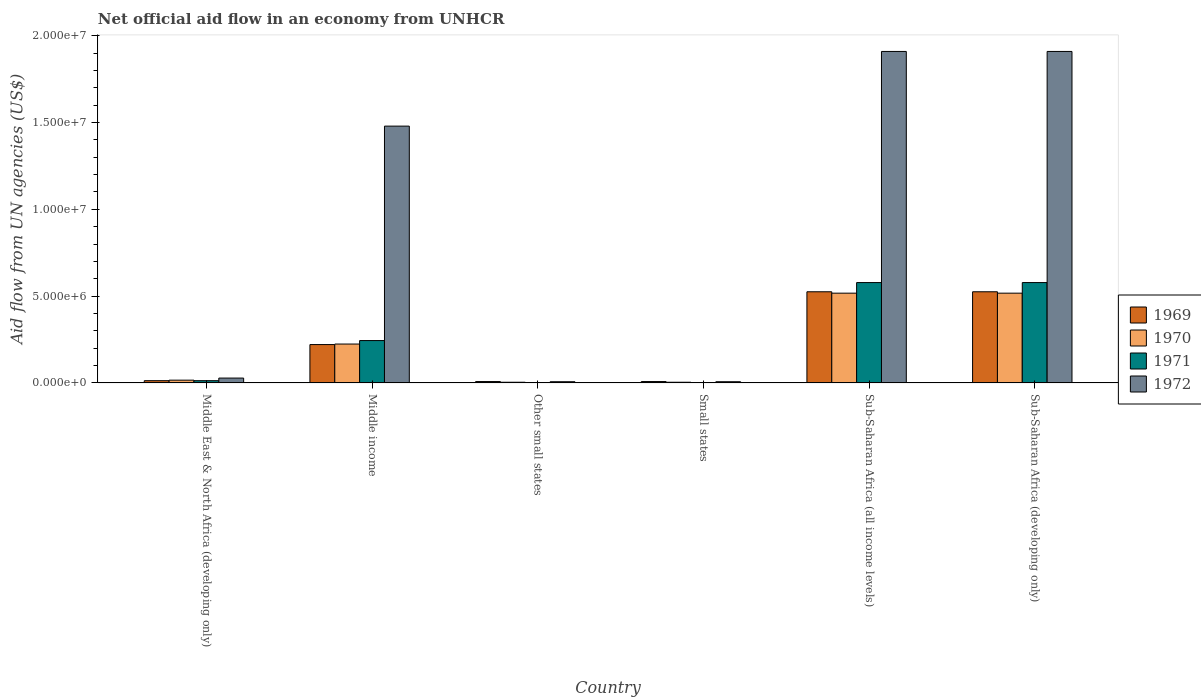How many groups of bars are there?
Make the answer very short. 6. Are the number of bars per tick equal to the number of legend labels?
Provide a succinct answer. Yes. Are the number of bars on each tick of the X-axis equal?
Offer a very short reply. Yes. How many bars are there on the 3rd tick from the left?
Provide a succinct answer. 4. How many bars are there on the 3rd tick from the right?
Offer a terse response. 4. What is the label of the 5th group of bars from the left?
Make the answer very short. Sub-Saharan Africa (all income levels). In how many cases, is the number of bars for a given country not equal to the number of legend labels?
Provide a succinct answer. 0. Across all countries, what is the maximum net official aid flow in 1969?
Give a very brief answer. 5.25e+06. Across all countries, what is the minimum net official aid flow in 1972?
Your answer should be very brief. 7.00e+04. In which country was the net official aid flow in 1971 maximum?
Provide a short and direct response. Sub-Saharan Africa (all income levels). In which country was the net official aid flow in 1971 minimum?
Your response must be concise. Other small states. What is the total net official aid flow in 1970 in the graph?
Give a very brief answer. 1.28e+07. What is the difference between the net official aid flow in 1970 in Middle income and that in Small states?
Provide a succinct answer. 2.20e+06. What is the difference between the net official aid flow in 1971 in Small states and the net official aid flow in 1969 in Other small states?
Keep it short and to the point. -6.00e+04. What is the average net official aid flow in 1969 per country?
Ensure brevity in your answer.  2.17e+06. What is the difference between the net official aid flow of/in 1972 and net official aid flow of/in 1969 in Sub-Saharan Africa (all income levels)?
Keep it short and to the point. 1.38e+07. In how many countries, is the net official aid flow in 1971 greater than 17000000 US$?
Your answer should be very brief. 0. What is the ratio of the net official aid flow in 1969 in Middle East & North Africa (developing only) to that in Sub-Saharan Africa (all income levels)?
Provide a short and direct response. 0.02. Is the net official aid flow in 1969 in Middle East & North Africa (developing only) less than that in Small states?
Keep it short and to the point. No. Is the difference between the net official aid flow in 1972 in Other small states and Sub-Saharan Africa (all income levels) greater than the difference between the net official aid flow in 1969 in Other small states and Sub-Saharan Africa (all income levels)?
Provide a succinct answer. No. What is the difference between the highest and the second highest net official aid flow in 1972?
Keep it short and to the point. 4.30e+06. What is the difference between the highest and the lowest net official aid flow in 1969?
Give a very brief answer. 5.17e+06. In how many countries, is the net official aid flow in 1971 greater than the average net official aid flow in 1971 taken over all countries?
Make the answer very short. 3. What does the 1st bar from the left in Middle East & North Africa (developing only) represents?
Offer a terse response. 1969. What does the 1st bar from the right in Sub-Saharan Africa (developing only) represents?
Ensure brevity in your answer.  1972. Is it the case that in every country, the sum of the net official aid flow in 1972 and net official aid flow in 1969 is greater than the net official aid flow in 1970?
Your response must be concise. Yes. Are all the bars in the graph horizontal?
Provide a short and direct response. No. How many countries are there in the graph?
Offer a terse response. 6. Does the graph contain grids?
Ensure brevity in your answer.  No. Where does the legend appear in the graph?
Keep it short and to the point. Center right. How many legend labels are there?
Provide a succinct answer. 4. What is the title of the graph?
Your answer should be compact. Net official aid flow in an economy from UNHCR. Does "1979" appear as one of the legend labels in the graph?
Your answer should be compact. No. What is the label or title of the X-axis?
Offer a very short reply. Country. What is the label or title of the Y-axis?
Offer a very short reply. Aid flow from UN agencies (US$). What is the Aid flow from UN agencies (US$) in 1970 in Middle East & North Africa (developing only)?
Offer a terse response. 1.60e+05. What is the Aid flow from UN agencies (US$) of 1972 in Middle East & North Africa (developing only)?
Provide a short and direct response. 2.80e+05. What is the Aid flow from UN agencies (US$) in 1969 in Middle income?
Provide a short and direct response. 2.21e+06. What is the Aid flow from UN agencies (US$) of 1970 in Middle income?
Offer a very short reply. 2.24e+06. What is the Aid flow from UN agencies (US$) of 1971 in Middle income?
Offer a very short reply. 2.44e+06. What is the Aid flow from UN agencies (US$) of 1972 in Middle income?
Provide a succinct answer. 1.48e+07. What is the Aid flow from UN agencies (US$) of 1970 in Other small states?
Your answer should be very brief. 4.00e+04. What is the Aid flow from UN agencies (US$) in 1972 in Other small states?
Make the answer very short. 7.00e+04. What is the Aid flow from UN agencies (US$) of 1969 in Small states?
Your answer should be very brief. 8.00e+04. What is the Aid flow from UN agencies (US$) in 1970 in Small states?
Your answer should be very brief. 4.00e+04. What is the Aid flow from UN agencies (US$) in 1971 in Small states?
Your response must be concise. 2.00e+04. What is the Aid flow from UN agencies (US$) of 1969 in Sub-Saharan Africa (all income levels)?
Ensure brevity in your answer.  5.25e+06. What is the Aid flow from UN agencies (US$) of 1970 in Sub-Saharan Africa (all income levels)?
Provide a succinct answer. 5.17e+06. What is the Aid flow from UN agencies (US$) of 1971 in Sub-Saharan Africa (all income levels)?
Your answer should be very brief. 5.78e+06. What is the Aid flow from UN agencies (US$) of 1972 in Sub-Saharan Africa (all income levels)?
Your response must be concise. 1.91e+07. What is the Aid flow from UN agencies (US$) of 1969 in Sub-Saharan Africa (developing only)?
Make the answer very short. 5.25e+06. What is the Aid flow from UN agencies (US$) of 1970 in Sub-Saharan Africa (developing only)?
Keep it short and to the point. 5.17e+06. What is the Aid flow from UN agencies (US$) in 1971 in Sub-Saharan Africa (developing only)?
Make the answer very short. 5.78e+06. What is the Aid flow from UN agencies (US$) in 1972 in Sub-Saharan Africa (developing only)?
Ensure brevity in your answer.  1.91e+07. Across all countries, what is the maximum Aid flow from UN agencies (US$) of 1969?
Make the answer very short. 5.25e+06. Across all countries, what is the maximum Aid flow from UN agencies (US$) of 1970?
Your answer should be very brief. 5.17e+06. Across all countries, what is the maximum Aid flow from UN agencies (US$) in 1971?
Make the answer very short. 5.78e+06. Across all countries, what is the maximum Aid flow from UN agencies (US$) of 1972?
Your answer should be compact. 1.91e+07. Across all countries, what is the minimum Aid flow from UN agencies (US$) in 1969?
Give a very brief answer. 8.00e+04. Across all countries, what is the minimum Aid flow from UN agencies (US$) in 1971?
Your answer should be very brief. 2.00e+04. What is the total Aid flow from UN agencies (US$) of 1969 in the graph?
Your answer should be compact. 1.30e+07. What is the total Aid flow from UN agencies (US$) of 1970 in the graph?
Ensure brevity in your answer.  1.28e+07. What is the total Aid flow from UN agencies (US$) of 1971 in the graph?
Give a very brief answer. 1.42e+07. What is the total Aid flow from UN agencies (US$) in 1972 in the graph?
Give a very brief answer. 5.34e+07. What is the difference between the Aid flow from UN agencies (US$) of 1969 in Middle East & North Africa (developing only) and that in Middle income?
Keep it short and to the point. -2.08e+06. What is the difference between the Aid flow from UN agencies (US$) in 1970 in Middle East & North Africa (developing only) and that in Middle income?
Your answer should be very brief. -2.08e+06. What is the difference between the Aid flow from UN agencies (US$) in 1971 in Middle East & North Africa (developing only) and that in Middle income?
Your response must be concise. -2.31e+06. What is the difference between the Aid flow from UN agencies (US$) in 1972 in Middle East & North Africa (developing only) and that in Middle income?
Make the answer very short. -1.45e+07. What is the difference between the Aid flow from UN agencies (US$) of 1969 in Middle East & North Africa (developing only) and that in Other small states?
Make the answer very short. 5.00e+04. What is the difference between the Aid flow from UN agencies (US$) of 1970 in Middle East & North Africa (developing only) and that in Other small states?
Make the answer very short. 1.20e+05. What is the difference between the Aid flow from UN agencies (US$) of 1971 in Middle East & North Africa (developing only) and that in Other small states?
Ensure brevity in your answer.  1.10e+05. What is the difference between the Aid flow from UN agencies (US$) of 1972 in Middle East & North Africa (developing only) and that in Small states?
Your answer should be compact. 2.10e+05. What is the difference between the Aid flow from UN agencies (US$) of 1969 in Middle East & North Africa (developing only) and that in Sub-Saharan Africa (all income levels)?
Make the answer very short. -5.12e+06. What is the difference between the Aid flow from UN agencies (US$) of 1970 in Middle East & North Africa (developing only) and that in Sub-Saharan Africa (all income levels)?
Offer a terse response. -5.01e+06. What is the difference between the Aid flow from UN agencies (US$) in 1971 in Middle East & North Africa (developing only) and that in Sub-Saharan Africa (all income levels)?
Keep it short and to the point. -5.65e+06. What is the difference between the Aid flow from UN agencies (US$) of 1972 in Middle East & North Africa (developing only) and that in Sub-Saharan Africa (all income levels)?
Provide a succinct answer. -1.88e+07. What is the difference between the Aid flow from UN agencies (US$) in 1969 in Middle East & North Africa (developing only) and that in Sub-Saharan Africa (developing only)?
Keep it short and to the point. -5.12e+06. What is the difference between the Aid flow from UN agencies (US$) in 1970 in Middle East & North Africa (developing only) and that in Sub-Saharan Africa (developing only)?
Make the answer very short. -5.01e+06. What is the difference between the Aid flow from UN agencies (US$) in 1971 in Middle East & North Africa (developing only) and that in Sub-Saharan Africa (developing only)?
Your answer should be compact. -5.65e+06. What is the difference between the Aid flow from UN agencies (US$) of 1972 in Middle East & North Africa (developing only) and that in Sub-Saharan Africa (developing only)?
Keep it short and to the point. -1.88e+07. What is the difference between the Aid flow from UN agencies (US$) in 1969 in Middle income and that in Other small states?
Make the answer very short. 2.13e+06. What is the difference between the Aid flow from UN agencies (US$) in 1970 in Middle income and that in Other small states?
Offer a very short reply. 2.20e+06. What is the difference between the Aid flow from UN agencies (US$) of 1971 in Middle income and that in Other small states?
Provide a short and direct response. 2.42e+06. What is the difference between the Aid flow from UN agencies (US$) in 1972 in Middle income and that in Other small states?
Your answer should be very brief. 1.47e+07. What is the difference between the Aid flow from UN agencies (US$) of 1969 in Middle income and that in Small states?
Give a very brief answer. 2.13e+06. What is the difference between the Aid flow from UN agencies (US$) of 1970 in Middle income and that in Small states?
Ensure brevity in your answer.  2.20e+06. What is the difference between the Aid flow from UN agencies (US$) in 1971 in Middle income and that in Small states?
Your response must be concise. 2.42e+06. What is the difference between the Aid flow from UN agencies (US$) in 1972 in Middle income and that in Small states?
Your answer should be compact. 1.47e+07. What is the difference between the Aid flow from UN agencies (US$) of 1969 in Middle income and that in Sub-Saharan Africa (all income levels)?
Offer a terse response. -3.04e+06. What is the difference between the Aid flow from UN agencies (US$) in 1970 in Middle income and that in Sub-Saharan Africa (all income levels)?
Offer a very short reply. -2.93e+06. What is the difference between the Aid flow from UN agencies (US$) in 1971 in Middle income and that in Sub-Saharan Africa (all income levels)?
Your answer should be compact. -3.34e+06. What is the difference between the Aid flow from UN agencies (US$) in 1972 in Middle income and that in Sub-Saharan Africa (all income levels)?
Keep it short and to the point. -4.30e+06. What is the difference between the Aid flow from UN agencies (US$) in 1969 in Middle income and that in Sub-Saharan Africa (developing only)?
Your answer should be very brief. -3.04e+06. What is the difference between the Aid flow from UN agencies (US$) in 1970 in Middle income and that in Sub-Saharan Africa (developing only)?
Provide a short and direct response. -2.93e+06. What is the difference between the Aid flow from UN agencies (US$) in 1971 in Middle income and that in Sub-Saharan Africa (developing only)?
Provide a short and direct response. -3.34e+06. What is the difference between the Aid flow from UN agencies (US$) of 1972 in Middle income and that in Sub-Saharan Africa (developing only)?
Make the answer very short. -4.30e+06. What is the difference between the Aid flow from UN agencies (US$) in 1969 in Other small states and that in Small states?
Ensure brevity in your answer.  0. What is the difference between the Aid flow from UN agencies (US$) of 1970 in Other small states and that in Small states?
Offer a terse response. 0. What is the difference between the Aid flow from UN agencies (US$) in 1971 in Other small states and that in Small states?
Your answer should be very brief. 0. What is the difference between the Aid flow from UN agencies (US$) of 1969 in Other small states and that in Sub-Saharan Africa (all income levels)?
Offer a very short reply. -5.17e+06. What is the difference between the Aid flow from UN agencies (US$) in 1970 in Other small states and that in Sub-Saharan Africa (all income levels)?
Provide a succinct answer. -5.13e+06. What is the difference between the Aid flow from UN agencies (US$) in 1971 in Other small states and that in Sub-Saharan Africa (all income levels)?
Keep it short and to the point. -5.76e+06. What is the difference between the Aid flow from UN agencies (US$) in 1972 in Other small states and that in Sub-Saharan Africa (all income levels)?
Offer a terse response. -1.90e+07. What is the difference between the Aid flow from UN agencies (US$) in 1969 in Other small states and that in Sub-Saharan Africa (developing only)?
Make the answer very short. -5.17e+06. What is the difference between the Aid flow from UN agencies (US$) of 1970 in Other small states and that in Sub-Saharan Africa (developing only)?
Your response must be concise. -5.13e+06. What is the difference between the Aid flow from UN agencies (US$) in 1971 in Other small states and that in Sub-Saharan Africa (developing only)?
Your answer should be very brief. -5.76e+06. What is the difference between the Aid flow from UN agencies (US$) in 1972 in Other small states and that in Sub-Saharan Africa (developing only)?
Provide a short and direct response. -1.90e+07. What is the difference between the Aid flow from UN agencies (US$) of 1969 in Small states and that in Sub-Saharan Africa (all income levels)?
Offer a very short reply. -5.17e+06. What is the difference between the Aid flow from UN agencies (US$) of 1970 in Small states and that in Sub-Saharan Africa (all income levels)?
Provide a succinct answer. -5.13e+06. What is the difference between the Aid flow from UN agencies (US$) of 1971 in Small states and that in Sub-Saharan Africa (all income levels)?
Make the answer very short. -5.76e+06. What is the difference between the Aid flow from UN agencies (US$) of 1972 in Small states and that in Sub-Saharan Africa (all income levels)?
Offer a terse response. -1.90e+07. What is the difference between the Aid flow from UN agencies (US$) in 1969 in Small states and that in Sub-Saharan Africa (developing only)?
Your response must be concise. -5.17e+06. What is the difference between the Aid flow from UN agencies (US$) in 1970 in Small states and that in Sub-Saharan Africa (developing only)?
Ensure brevity in your answer.  -5.13e+06. What is the difference between the Aid flow from UN agencies (US$) in 1971 in Small states and that in Sub-Saharan Africa (developing only)?
Ensure brevity in your answer.  -5.76e+06. What is the difference between the Aid flow from UN agencies (US$) of 1972 in Small states and that in Sub-Saharan Africa (developing only)?
Your answer should be very brief. -1.90e+07. What is the difference between the Aid flow from UN agencies (US$) of 1969 in Sub-Saharan Africa (all income levels) and that in Sub-Saharan Africa (developing only)?
Your response must be concise. 0. What is the difference between the Aid flow from UN agencies (US$) in 1972 in Sub-Saharan Africa (all income levels) and that in Sub-Saharan Africa (developing only)?
Give a very brief answer. 0. What is the difference between the Aid flow from UN agencies (US$) of 1969 in Middle East & North Africa (developing only) and the Aid flow from UN agencies (US$) of 1970 in Middle income?
Your answer should be compact. -2.11e+06. What is the difference between the Aid flow from UN agencies (US$) of 1969 in Middle East & North Africa (developing only) and the Aid flow from UN agencies (US$) of 1971 in Middle income?
Your answer should be very brief. -2.31e+06. What is the difference between the Aid flow from UN agencies (US$) of 1969 in Middle East & North Africa (developing only) and the Aid flow from UN agencies (US$) of 1972 in Middle income?
Make the answer very short. -1.47e+07. What is the difference between the Aid flow from UN agencies (US$) of 1970 in Middle East & North Africa (developing only) and the Aid flow from UN agencies (US$) of 1971 in Middle income?
Keep it short and to the point. -2.28e+06. What is the difference between the Aid flow from UN agencies (US$) in 1970 in Middle East & North Africa (developing only) and the Aid flow from UN agencies (US$) in 1972 in Middle income?
Ensure brevity in your answer.  -1.46e+07. What is the difference between the Aid flow from UN agencies (US$) of 1971 in Middle East & North Africa (developing only) and the Aid flow from UN agencies (US$) of 1972 in Middle income?
Your response must be concise. -1.47e+07. What is the difference between the Aid flow from UN agencies (US$) in 1969 in Middle East & North Africa (developing only) and the Aid flow from UN agencies (US$) in 1970 in Other small states?
Your response must be concise. 9.00e+04. What is the difference between the Aid flow from UN agencies (US$) in 1969 in Middle East & North Africa (developing only) and the Aid flow from UN agencies (US$) in 1972 in Other small states?
Offer a very short reply. 6.00e+04. What is the difference between the Aid flow from UN agencies (US$) of 1970 in Middle East & North Africa (developing only) and the Aid flow from UN agencies (US$) of 1971 in Other small states?
Offer a terse response. 1.40e+05. What is the difference between the Aid flow from UN agencies (US$) of 1971 in Middle East & North Africa (developing only) and the Aid flow from UN agencies (US$) of 1972 in Other small states?
Ensure brevity in your answer.  6.00e+04. What is the difference between the Aid flow from UN agencies (US$) in 1970 in Middle East & North Africa (developing only) and the Aid flow from UN agencies (US$) in 1971 in Small states?
Your answer should be very brief. 1.40e+05. What is the difference between the Aid flow from UN agencies (US$) in 1969 in Middle East & North Africa (developing only) and the Aid flow from UN agencies (US$) in 1970 in Sub-Saharan Africa (all income levels)?
Offer a very short reply. -5.04e+06. What is the difference between the Aid flow from UN agencies (US$) in 1969 in Middle East & North Africa (developing only) and the Aid flow from UN agencies (US$) in 1971 in Sub-Saharan Africa (all income levels)?
Ensure brevity in your answer.  -5.65e+06. What is the difference between the Aid flow from UN agencies (US$) of 1969 in Middle East & North Africa (developing only) and the Aid flow from UN agencies (US$) of 1972 in Sub-Saharan Africa (all income levels)?
Your answer should be compact. -1.90e+07. What is the difference between the Aid flow from UN agencies (US$) of 1970 in Middle East & North Africa (developing only) and the Aid flow from UN agencies (US$) of 1971 in Sub-Saharan Africa (all income levels)?
Offer a very short reply. -5.62e+06. What is the difference between the Aid flow from UN agencies (US$) in 1970 in Middle East & North Africa (developing only) and the Aid flow from UN agencies (US$) in 1972 in Sub-Saharan Africa (all income levels)?
Offer a very short reply. -1.89e+07. What is the difference between the Aid flow from UN agencies (US$) in 1971 in Middle East & North Africa (developing only) and the Aid flow from UN agencies (US$) in 1972 in Sub-Saharan Africa (all income levels)?
Provide a short and direct response. -1.90e+07. What is the difference between the Aid flow from UN agencies (US$) of 1969 in Middle East & North Africa (developing only) and the Aid flow from UN agencies (US$) of 1970 in Sub-Saharan Africa (developing only)?
Provide a short and direct response. -5.04e+06. What is the difference between the Aid flow from UN agencies (US$) of 1969 in Middle East & North Africa (developing only) and the Aid flow from UN agencies (US$) of 1971 in Sub-Saharan Africa (developing only)?
Provide a succinct answer. -5.65e+06. What is the difference between the Aid flow from UN agencies (US$) in 1969 in Middle East & North Africa (developing only) and the Aid flow from UN agencies (US$) in 1972 in Sub-Saharan Africa (developing only)?
Your answer should be compact. -1.90e+07. What is the difference between the Aid flow from UN agencies (US$) in 1970 in Middle East & North Africa (developing only) and the Aid flow from UN agencies (US$) in 1971 in Sub-Saharan Africa (developing only)?
Offer a very short reply. -5.62e+06. What is the difference between the Aid flow from UN agencies (US$) in 1970 in Middle East & North Africa (developing only) and the Aid flow from UN agencies (US$) in 1972 in Sub-Saharan Africa (developing only)?
Keep it short and to the point. -1.89e+07. What is the difference between the Aid flow from UN agencies (US$) of 1971 in Middle East & North Africa (developing only) and the Aid flow from UN agencies (US$) of 1972 in Sub-Saharan Africa (developing only)?
Provide a succinct answer. -1.90e+07. What is the difference between the Aid flow from UN agencies (US$) in 1969 in Middle income and the Aid flow from UN agencies (US$) in 1970 in Other small states?
Provide a short and direct response. 2.17e+06. What is the difference between the Aid flow from UN agencies (US$) of 1969 in Middle income and the Aid flow from UN agencies (US$) of 1971 in Other small states?
Keep it short and to the point. 2.19e+06. What is the difference between the Aid flow from UN agencies (US$) in 1969 in Middle income and the Aid flow from UN agencies (US$) in 1972 in Other small states?
Give a very brief answer. 2.14e+06. What is the difference between the Aid flow from UN agencies (US$) of 1970 in Middle income and the Aid flow from UN agencies (US$) of 1971 in Other small states?
Offer a very short reply. 2.22e+06. What is the difference between the Aid flow from UN agencies (US$) in 1970 in Middle income and the Aid flow from UN agencies (US$) in 1972 in Other small states?
Provide a short and direct response. 2.17e+06. What is the difference between the Aid flow from UN agencies (US$) in 1971 in Middle income and the Aid flow from UN agencies (US$) in 1972 in Other small states?
Offer a very short reply. 2.37e+06. What is the difference between the Aid flow from UN agencies (US$) in 1969 in Middle income and the Aid flow from UN agencies (US$) in 1970 in Small states?
Make the answer very short. 2.17e+06. What is the difference between the Aid flow from UN agencies (US$) in 1969 in Middle income and the Aid flow from UN agencies (US$) in 1971 in Small states?
Offer a very short reply. 2.19e+06. What is the difference between the Aid flow from UN agencies (US$) in 1969 in Middle income and the Aid flow from UN agencies (US$) in 1972 in Small states?
Provide a short and direct response. 2.14e+06. What is the difference between the Aid flow from UN agencies (US$) of 1970 in Middle income and the Aid flow from UN agencies (US$) of 1971 in Small states?
Keep it short and to the point. 2.22e+06. What is the difference between the Aid flow from UN agencies (US$) in 1970 in Middle income and the Aid flow from UN agencies (US$) in 1972 in Small states?
Offer a very short reply. 2.17e+06. What is the difference between the Aid flow from UN agencies (US$) in 1971 in Middle income and the Aid flow from UN agencies (US$) in 1972 in Small states?
Keep it short and to the point. 2.37e+06. What is the difference between the Aid flow from UN agencies (US$) of 1969 in Middle income and the Aid flow from UN agencies (US$) of 1970 in Sub-Saharan Africa (all income levels)?
Offer a terse response. -2.96e+06. What is the difference between the Aid flow from UN agencies (US$) of 1969 in Middle income and the Aid flow from UN agencies (US$) of 1971 in Sub-Saharan Africa (all income levels)?
Provide a succinct answer. -3.57e+06. What is the difference between the Aid flow from UN agencies (US$) in 1969 in Middle income and the Aid flow from UN agencies (US$) in 1972 in Sub-Saharan Africa (all income levels)?
Keep it short and to the point. -1.69e+07. What is the difference between the Aid flow from UN agencies (US$) in 1970 in Middle income and the Aid flow from UN agencies (US$) in 1971 in Sub-Saharan Africa (all income levels)?
Ensure brevity in your answer.  -3.54e+06. What is the difference between the Aid flow from UN agencies (US$) of 1970 in Middle income and the Aid flow from UN agencies (US$) of 1972 in Sub-Saharan Africa (all income levels)?
Provide a short and direct response. -1.68e+07. What is the difference between the Aid flow from UN agencies (US$) of 1971 in Middle income and the Aid flow from UN agencies (US$) of 1972 in Sub-Saharan Africa (all income levels)?
Give a very brief answer. -1.66e+07. What is the difference between the Aid flow from UN agencies (US$) of 1969 in Middle income and the Aid flow from UN agencies (US$) of 1970 in Sub-Saharan Africa (developing only)?
Make the answer very short. -2.96e+06. What is the difference between the Aid flow from UN agencies (US$) in 1969 in Middle income and the Aid flow from UN agencies (US$) in 1971 in Sub-Saharan Africa (developing only)?
Give a very brief answer. -3.57e+06. What is the difference between the Aid flow from UN agencies (US$) of 1969 in Middle income and the Aid flow from UN agencies (US$) of 1972 in Sub-Saharan Africa (developing only)?
Make the answer very short. -1.69e+07. What is the difference between the Aid flow from UN agencies (US$) of 1970 in Middle income and the Aid flow from UN agencies (US$) of 1971 in Sub-Saharan Africa (developing only)?
Provide a short and direct response. -3.54e+06. What is the difference between the Aid flow from UN agencies (US$) in 1970 in Middle income and the Aid flow from UN agencies (US$) in 1972 in Sub-Saharan Africa (developing only)?
Provide a short and direct response. -1.68e+07. What is the difference between the Aid flow from UN agencies (US$) in 1971 in Middle income and the Aid flow from UN agencies (US$) in 1972 in Sub-Saharan Africa (developing only)?
Your answer should be compact. -1.66e+07. What is the difference between the Aid flow from UN agencies (US$) in 1969 in Other small states and the Aid flow from UN agencies (US$) in 1971 in Small states?
Your response must be concise. 6.00e+04. What is the difference between the Aid flow from UN agencies (US$) of 1969 in Other small states and the Aid flow from UN agencies (US$) of 1970 in Sub-Saharan Africa (all income levels)?
Provide a succinct answer. -5.09e+06. What is the difference between the Aid flow from UN agencies (US$) of 1969 in Other small states and the Aid flow from UN agencies (US$) of 1971 in Sub-Saharan Africa (all income levels)?
Your answer should be very brief. -5.70e+06. What is the difference between the Aid flow from UN agencies (US$) in 1969 in Other small states and the Aid flow from UN agencies (US$) in 1972 in Sub-Saharan Africa (all income levels)?
Your answer should be very brief. -1.90e+07. What is the difference between the Aid flow from UN agencies (US$) of 1970 in Other small states and the Aid flow from UN agencies (US$) of 1971 in Sub-Saharan Africa (all income levels)?
Your answer should be compact. -5.74e+06. What is the difference between the Aid flow from UN agencies (US$) in 1970 in Other small states and the Aid flow from UN agencies (US$) in 1972 in Sub-Saharan Africa (all income levels)?
Offer a terse response. -1.90e+07. What is the difference between the Aid flow from UN agencies (US$) in 1971 in Other small states and the Aid flow from UN agencies (US$) in 1972 in Sub-Saharan Africa (all income levels)?
Give a very brief answer. -1.91e+07. What is the difference between the Aid flow from UN agencies (US$) of 1969 in Other small states and the Aid flow from UN agencies (US$) of 1970 in Sub-Saharan Africa (developing only)?
Your answer should be very brief. -5.09e+06. What is the difference between the Aid flow from UN agencies (US$) in 1969 in Other small states and the Aid flow from UN agencies (US$) in 1971 in Sub-Saharan Africa (developing only)?
Ensure brevity in your answer.  -5.70e+06. What is the difference between the Aid flow from UN agencies (US$) of 1969 in Other small states and the Aid flow from UN agencies (US$) of 1972 in Sub-Saharan Africa (developing only)?
Keep it short and to the point. -1.90e+07. What is the difference between the Aid flow from UN agencies (US$) of 1970 in Other small states and the Aid flow from UN agencies (US$) of 1971 in Sub-Saharan Africa (developing only)?
Make the answer very short. -5.74e+06. What is the difference between the Aid flow from UN agencies (US$) in 1970 in Other small states and the Aid flow from UN agencies (US$) in 1972 in Sub-Saharan Africa (developing only)?
Give a very brief answer. -1.90e+07. What is the difference between the Aid flow from UN agencies (US$) in 1971 in Other small states and the Aid flow from UN agencies (US$) in 1972 in Sub-Saharan Africa (developing only)?
Keep it short and to the point. -1.91e+07. What is the difference between the Aid flow from UN agencies (US$) of 1969 in Small states and the Aid flow from UN agencies (US$) of 1970 in Sub-Saharan Africa (all income levels)?
Provide a short and direct response. -5.09e+06. What is the difference between the Aid flow from UN agencies (US$) of 1969 in Small states and the Aid flow from UN agencies (US$) of 1971 in Sub-Saharan Africa (all income levels)?
Offer a very short reply. -5.70e+06. What is the difference between the Aid flow from UN agencies (US$) in 1969 in Small states and the Aid flow from UN agencies (US$) in 1972 in Sub-Saharan Africa (all income levels)?
Provide a succinct answer. -1.90e+07. What is the difference between the Aid flow from UN agencies (US$) of 1970 in Small states and the Aid flow from UN agencies (US$) of 1971 in Sub-Saharan Africa (all income levels)?
Keep it short and to the point. -5.74e+06. What is the difference between the Aid flow from UN agencies (US$) in 1970 in Small states and the Aid flow from UN agencies (US$) in 1972 in Sub-Saharan Africa (all income levels)?
Give a very brief answer. -1.90e+07. What is the difference between the Aid flow from UN agencies (US$) in 1971 in Small states and the Aid flow from UN agencies (US$) in 1972 in Sub-Saharan Africa (all income levels)?
Provide a short and direct response. -1.91e+07. What is the difference between the Aid flow from UN agencies (US$) in 1969 in Small states and the Aid flow from UN agencies (US$) in 1970 in Sub-Saharan Africa (developing only)?
Provide a succinct answer. -5.09e+06. What is the difference between the Aid flow from UN agencies (US$) in 1969 in Small states and the Aid flow from UN agencies (US$) in 1971 in Sub-Saharan Africa (developing only)?
Provide a succinct answer. -5.70e+06. What is the difference between the Aid flow from UN agencies (US$) in 1969 in Small states and the Aid flow from UN agencies (US$) in 1972 in Sub-Saharan Africa (developing only)?
Offer a terse response. -1.90e+07. What is the difference between the Aid flow from UN agencies (US$) of 1970 in Small states and the Aid flow from UN agencies (US$) of 1971 in Sub-Saharan Africa (developing only)?
Your answer should be compact. -5.74e+06. What is the difference between the Aid flow from UN agencies (US$) in 1970 in Small states and the Aid flow from UN agencies (US$) in 1972 in Sub-Saharan Africa (developing only)?
Keep it short and to the point. -1.90e+07. What is the difference between the Aid flow from UN agencies (US$) in 1971 in Small states and the Aid flow from UN agencies (US$) in 1972 in Sub-Saharan Africa (developing only)?
Offer a terse response. -1.91e+07. What is the difference between the Aid flow from UN agencies (US$) in 1969 in Sub-Saharan Africa (all income levels) and the Aid flow from UN agencies (US$) in 1970 in Sub-Saharan Africa (developing only)?
Provide a short and direct response. 8.00e+04. What is the difference between the Aid flow from UN agencies (US$) of 1969 in Sub-Saharan Africa (all income levels) and the Aid flow from UN agencies (US$) of 1971 in Sub-Saharan Africa (developing only)?
Offer a terse response. -5.30e+05. What is the difference between the Aid flow from UN agencies (US$) of 1969 in Sub-Saharan Africa (all income levels) and the Aid flow from UN agencies (US$) of 1972 in Sub-Saharan Africa (developing only)?
Provide a short and direct response. -1.38e+07. What is the difference between the Aid flow from UN agencies (US$) in 1970 in Sub-Saharan Africa (all income levels) and the Aid flow from UN agencies (US$) in 1971 in Sub-Saharan Africa (developing only)?
Offer a terse response. -6.10e+05. What is the difference between the Aid flow from UN agencies (US$) in 1970 in Sub-Saharan Africa (all income levels) and the Aid flow from UN agencies (US$) in 1972 in Sub-Saharan Africa (developing only)?
Your answer should be very brief. -1.39e+07. What is the difference between the Aid flow from UN agencies (US$) in 1971 in Sub-Saharan Africa (all income levels) and the Aid flow from UN agencies (US$) in 1972 in Sub-Saharan Africa (developing only)?
Make the answer very short. -1.33e+07. What is the average Aid flow from UN agencies (US$) in 1969 per country?
Offer a very short reply. 2.17e+06. What is the average Aid flow from UN agencies (US$) of 1970 per country?
Give a very brief answer. 2.14e+06. What is the average Aid flow from UN agencies (US$) of 1971 per country?
Ensure brevity in your answer.  2.36e+06. What is the average Aid flow from UN agencies (US$) of 1972 per country?
Offer a terse response. 8.90e+06. What is the difference between the Aid flow from UN agencies (US$) of 1969 and Aid flow from UN agencies (US$) of 1970 in Middle East & North Africa (developing only)?
Provide a succinct answer. -3.00e+04. What is the difference between the Aid flow from UN agencies (US$) in 1969 and Aid flow from UN agencies (US$) in 1971 in Middle East & North Africa (developing only)?
Make the answer very short. 0. What is the difference between the Aid flow from UN agencies (US$) of 1969 and Aid flow from UN agencies (US$) of 1972 in Middle East & North Africa (developing only)?
Provide a succinct answer. -1.50e+05. What is the difference between the Aid flow from UN agencies (US$) in 1970 and Aid flow from UN agencies (US$) in 1972 in Middle East & North Africa (developing only)?
Your response must be concise. -1.20e+05. What is the difference between the Aid flow from UN agencies (US$) of 1971 and Aid flow from UN agencies (US$) of 1972 in Middle East & North Africa (developing only)?
Offer a very short reply. -1.50e+05. What is the difference between the Aid flow from UN agencies (US$) of 1969 and Aid flow from UN agencies (US$) of 1970 in Middle income?
Provide a succinct answer. -3.00e+04. What is the difference between the Aid flow from UN agencies (US$) in 1969 and Aid flow from UN agencies (US$) in 1972 in Middle income?
Your answer should be very brief. -1.26e+07. What is the difference between the Aid flow from UN agencies (US$) in 1970 and Aid flow from UN agencies (US$) in 1971 in Middle income?
Keep it short and to the point. -2.00e+05. What is the difference between the Aid flow from UN agencies (US$) in 1970 and Aid flow from UN agencies (US$) in 1972 in Middle income?
Give a very brief answer. -1.26e+07. What is the difference between the Aid flow from UN agencies (US$) of 1971 and Aid flow from UN agencies (US$) of 1972 in Middle income?
Offer a terse response. -1.24e+07. What is the difference between the Aid flow from UN agencies (US$) in 1970 and Aid flow from UN agencies (US$) in 1972 in Other small states?
Keep it short and to the point. -3.00e+04. What is the difference between the Aid flow from UN agencies (US$) of 1969 and Aid flow from UN agencies (US$) of 1970 in Small states?
Keep it short and to the point. 4.00e+04. What is the difference between the Aid flow from UN agencies (US$) in 1970 and Aid flow from UN agencies (US$) in 1971 in Small states?
Your answer should be compact. 2.00e+04. What is the difference between the Aid flow from UN agencies (US$) of 1971 and Aid flow from UN agencies (US$) of 1972 in Small states?
Offer a terse response. -5.00e+04. What is the difference between the Aid flow from UN agencies (US$) of 1969 and Aid flow from UN agencies (US$) of 1971 in Sub-Saharan Africa (all income levels)?
Make the answer very short. -5.30e+05. What is the difference between the Aid flow from UN agencies (US$) of 1969 and Aid flow from UN agencies (US$) of 1972 in Sub-Saharan Africa (all income levels)?
Offer a terse response. -1.38e+07. What is the difference between the Aid flow from UN agencies (US$) of 1970 and Aid flow from UN agencies (US$) of 1971 in Sub-Saharan Africa (all income levels)?
Offer a very short reply. -6.10e+05. What is the difference between the Aid flow from UN agencies (US$) of 1970 and Aid flow from UN agencies (US$) of 1972 in Sub-Saharan Africa (all income levels)?
Keep it short and to the point. -1.39e+07. What is the difference between the Aid flow from UN agencies (US$) of 1971 and Aid flow from UN agencies (US$) of 1972 in Sub-Saharan Africa (all income levels)?
Provide a short and direct response. -1.33e+07. What is the difference between the Aid flow from UN agencies (US$) of 1969 and Aid flow from UN agencies (US$) of 1970 in Sub-Saharan Africa (developing only)?
Offer a very short reply. 8.00e+04. What is the difference between the Aid flow from UN agencies (US$) in 1969 and Aid flow from UN agencies (US$) in 1971 in Sub-Saharan Africa (developing only)?
Give a very brief answer. -5.30e+05. What is the difference between the Aid flow from UN agencies (US$) in 1969 and Aid flow from UN agencies (US$) in 1972 in Sub-Saharan Africa (developing only)?
Offer a terse response. -1.38e+07. What is the difference between the Aid flow from UN agencies (US$) of 1970 and Aid flow from UN agencies (US$) of 1971 in Sub-Saharan Africa (developing only)?
Provide a short and direct response. -6.10e+05. What is the difference between the Aid flow from UN agencies (US$) in 1970 and Aid flow from UN agencies (US$) in 1972 in Sub-Saharan Africa (developing only)?
Your answer should be compact. -1.39e+07. What is the difference between the Aid flow from UN agencies (US$) in 1971 and Aid flow from UN agencies (US$) in 1972 in Sub-Saharan Africa (developing only)?
Your answer should be very brief. -1.33e+07. What is the ratio of the Aid flow from UN agencies (US$) of 1969 in Middle East & North Africa (developing only) to that in Middle income?
Make the answer very short. 0.06. What is the ratio of the Aid flow from UN agencies (US$) in 1970 in Middle East & North Africa (developing only) to that in Middle income?
Provide a succinct answer. 0.07. What is the ratio of the Aid flow from UN agencies (US$) in 1971 in Middle East & North Africa (developing only) to that in Middle income?
Give a very brief answer. 0.05. What is the ratio of the Aid flow from UN agencies (US$) of 1972 in Middle East & North Africa (developing only) to that in Middle income?
Provide a succinct answer. 0.02. What is the ratio of the Aid flow from UN agencies (US$) of 1969 in Middle East & North Africa (developing only) to that in Other small states?
Offer a terse response. 1.62. What is the ratio of the Aid flow from UN agencies (US$) of 1971 in Middle East & North Africa (developing only) to that in Other small states?
Your response must be concise. 6.5. What is the ratio of the Aid flow from UN agencies (US$) of 1972 in Middle East & North Africa (developing only) to that in Other small states?
Provide a succinct answer. 4. What is the ratio of the Aid flow from UN agencies (US$) in 1969 in Middle East & North Africa (developing only) to that in Small states?
Your answer should be very brief. 1.62. What is the ratio of the Aid flow from UN agencies (US$) of 1971 in Middle East & North Africa (developing only) to that in Small states?
Provide a succinct answer. 6.5. What is the ratio of the Aid flow from UN agencies (US$) of 1969 in Middle East & North Africa (developing only) to that in Sub-Saharan Africa (all income levels)?
Offer a very short reply. 0.02. What is the ratio of the Aid flow from UN agencies (US$) of 1970 in Middle East & North Africa (developing only) to that in Sub-Saharan Africa (all income levels)?
Give a very brief answer. 0.03. What is the ratio of the Aid flow from UN agencies (US$) in 1971 in Middle East & North Africa (developing only) to that in Sub-Saharan Africa (all income levels)?
Offer a very short reply. 0.02. What is the ratio of the Aid flow from UN agencies (US$) of 1972 in Middle East & North Africa (developing only) to that in Sub-Saharan Africa (all income levels)?
Keep it short and to the point. 0.01. What is the ratio of the Aid flow from UN agencies (US$) of 1969 in Middle East & North Africa (developing only) to that in Sub-Saharan Africa (developing only)?
Your answer should be compact. 0.02. What is the ratio of the Aid flow from UN agencies (US$) in 1970 in Middle East & North Africa (developing only) to that in Sub-Saharan Africa (developing only)?
Make the answer very short. 0.03. What is the ratio of the Aid flow from UN agencies (US$) of 1971 in Middle East & North Africa (developing only) to that in Sub-Saharan Africa (developing only)?
Your answer should be very brief. 0.02. What is the ratio of the Aid flow from UN agencies (US$) in 1972 in Middle East & North Africa (developing only) to that in Sub-Saharan Africa (developing only)?
Keep it short and to the point. 0.01. What is the ratio of the Aid flow from UN agencies (US$) of 1969 in Middle income to that in Other small states?
Make the answer very short. 27.62. What is the ratio of the Aid flow from UN agencies (US$) in 1971 in Middle income to that in Other small states?
Ensure brevity in your answer.  122. What is the ratio of the Aid flow from UN agencies (US$) of 1972 in Middle income to that in Other small states?
Keep it short and to the point. 211.29. What is the ratio of the Aid flow from UN agencies (US$) in 1969 in Middle income to that in Small states?
Provide a short and direct response. 27.62. What is the ratio of the Aid flow from UN agencies (US$) of 1970 in Middle income to that in Small states?
Offer a terse response. 56. What is the ratio of the Aid flow from UN agencies (US$) in 1971 in Middle income to that in Small states?
Offer a very short reply. 122. What is the ratio of the Aid flow from UN agencies (US$) of 1972 in Middle income to that in Small states?
Offer a very short reply. 211.29. What is the ratio of the Aid flow from UN agencies (US$) in 1969 in Middle income to that in Sub-Saharan Africa (all income levels)?
Your response must be concise. 0.42. What is the ratio of the Aid flow from UN agencies (US$) of 1970 in Middle income to that in Sub-Saharan Africa (all income levels)?
Provide a short and direct response. 0.43. What is the ratio of the Aid flow from UN agencies (US$) of 1971 in Middle income to that in Sub-Saharan Africa (all income levels)?
Keep it short and to the point. 0.42. What is the ratio of the Aid flow from UN agencies (US$) of 1972 in Middle income to that in Sub-Saharan Africa (all income levels)?
Your answer should be very brief. 0.77. What is the ratio of the Aid flow from UN agencies (US$) of 1969 in Middle income to that in Sub-Saharan Africa (developing only)?
Offer a terse response. 0.42. What is the ratio of the Aid flow from UN agencies (US$) of 1970 in Middle income to that in Sub-Saharan Africa (developing only)?
Give a very brief answer. 0.43. What is the ratio of the Aid flow from UN agencies (US$) in 1971 in Middle income to that in Sub-Saharan Africa (developing only)?
Make the answer very short. 0.42. What is the ratio of the Aid flow from UN agencies (US$) in 1972 in Middle income to that in Sub-Saharan Africa (developing only)?
Ensure brevity in your answer.  0.77. What is the ratio of the Aid flow from UN agencies (US$) in 1969 in Other small states to that in Small states?
Give a very brief answer. 1. What is the ratio of the Aid flow from UN agencies (US$) in 1971 in Other small states to that in Small states?
Give a very brief answer. 1. What is the ratio of the Aid flow from UN agencies (US$) in 1969 in Other small states to that in Sub-Saharan Africa (all income levels)?
Provide a succinct answer. 0.02. What is the ratio of the Aid flow from UN agencies (US$) in 1970 in Other small states to that in Sub-Saharan Africa (all income levels)?
Provide a short and direct response. 0.01. What is the ratio of the Aid flow from UN agencies (US$) in 1971 in Other small states to that in Sub-Saharan Africa (all income levels)?
Offer a very short reply. 0. What is the ratio of the Aid flow from UN agencies (US$) of 1972 in Other small states to that in Sub-Saharan Africa (all income levels)?
Your response must be concise. 0. What is the ratio of the Aid flow from UN agencies (US$) of 1969 in Other small states to that in Sub-Saharan Africa (developing only)?
Make the answer very short. 0.02. What is the ratio of the Aid flow from UN agencies (US$) of 1970 in Other small states to that in Sub-Saharan Africa (developing only)?
Your answer should be very brief. 0.01. What is the ratio of the Aid flow from UN agencies (US$) of 1971 in Other small states to that in Sub-Saharan Africa (developing only)?
Ensure brevity in your answer.  0. What is the ratio of the Aid flow from UN agencies (US$) of 1972 in Other small states to that in Sub-Saharan Africa (developing only)?
Your response must be concise. 0. What is the ratio of the Aid flow from UN agencies (US$) in 1969 in Small states to that in Sub-Saharan Africa (all income levels)?
Your answer should be compact. 0.02. What is the ratio of the Aid flow from UN agencies (US$) of 1970 in Small states to that in Sub-Saharan Africa (all income levels)?
Your response must be concise. 0.01. What is the ratio of the Aid flow from UN agencies (US$) in 1971 in Small states to that in Sub-Saharan Africa (all income levels)?
Your response must be concise. 0. What is the ratio of the Aid flow from UN agencies (US$) in 1972 in Small states to that in Sub-Saharan Africa (all income levels)?
Keep it short and to the point. 0. What is the ratio of the Aid flow from UN agencies (US$) of 1969 in Small states to that in Sub-Saharan Africa (developing only)?
Make the answer very short. 0.02. What is the ratio of the Aid flow from UN agencies (US$) in 1970 in Small states to that in Sub-Saharan Africa (developing only)?
Your answer should be very brief. 0.01. What is the ratio of the Aid flow from UN agencies (US$) of 1971 in Small states to that in Sub-Saharan Africa (developing only)?
Offer a terse response. 0. What is the ratio of the Aid flow from UN agencies (US$) of 1972 in Small states to that in Sub-Saharan Africa (developing only)?
Your answer should be compact. 0. What is the ratio of the Aid flow from UN agencies (US$) in 1970 in Sub-Saharan Africa (all income levels) to that in Sub-Saharan Africa (developing only)?
Offer a very short reply. 1. What is the difference between the highest and the second highest Aid flow from UN agencies (US$) of 1970?
Provide a short and direct response. 0. What is the difference between the highest and the lowest Aid flow from UN agencies (US$) in 1969?
Keep it short and to the point. 5.17e+06. What is the difference between the highest and the lowest Aid flow from UN agencies (US$) of 1970?
Provide a succinct answer. 5.13e+06. What is the difference between the highest and the lowest Aid flow from UN agencies (US$) in 1971?
Make the answer very short. 5.76e+06. What is the difference between the highest and the lowest Aid flow from UN agencies (US$) in 1972?
Offer a very short reply. 1.90e+07. 